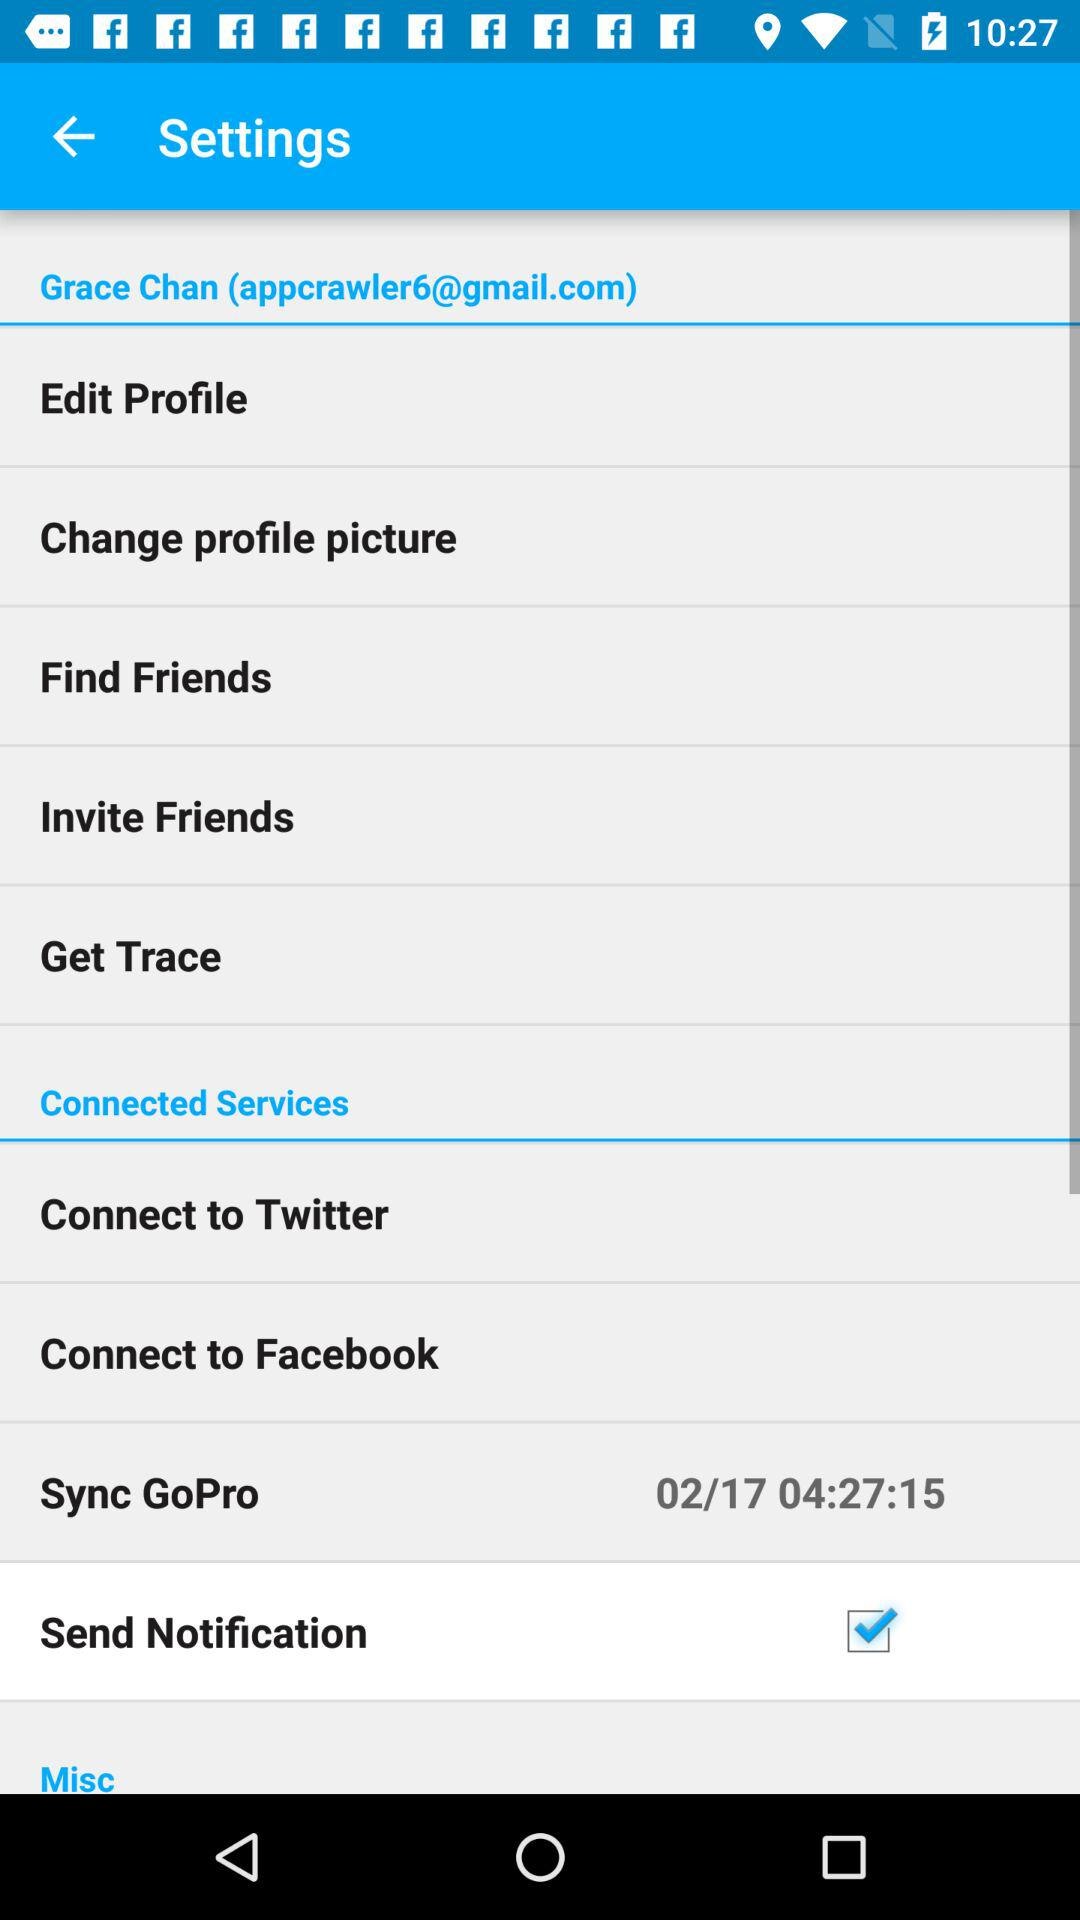Which is the year of sync GoPro?
When the provided information is insufficient, respond with <no answer>. <no answer> 